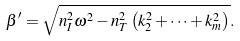Convert formula to latex. <formula><loc_0><loc_0><loc_500><loc_500>\beta ^ { \prime } = \sqrt { n _ { I } ^ { 2 } \omega ^ { 2 } - n _ { T } ^ { 2 } \left ( k _ { 2 } ^ { 2 } + \cdots + k _ { m } ^ { 2 } \right ) } .</formula> 